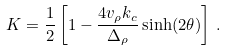<formula> <loc_0><loc_0><loc_500><loc_500>K = \frac { 1 } { 2 } \left [ 1 - \frac { 4 v _ { \rho } k _ { c } } { \Delta _ { \rho } } \sinh ( 2 \theta ) \right ] \, .</formula> 